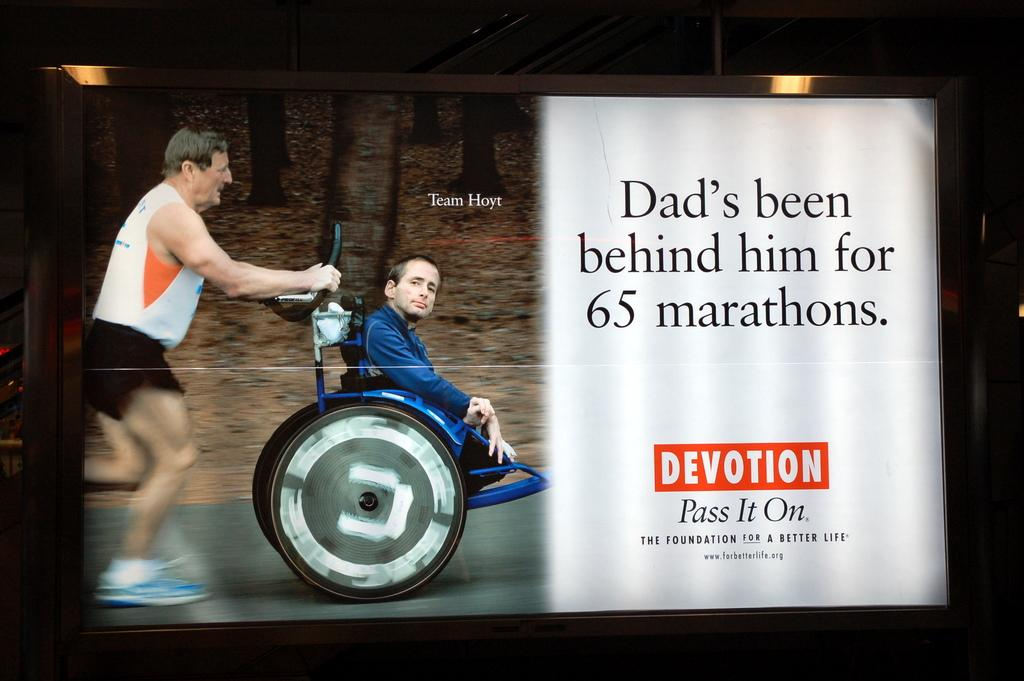What is the main subject of the image? The main subject of the image is a screen. What can be seen on the screen? Two people, a wheelchair, trees, and some text are visible on the screen. Can you describe the people on the screen? Unfortunately, the image does not provide enough detail to describe the people on the screen. What is the color of the background in the image? The background of the image is dark. How many ladybugs are crawling on the gold cannon in the image? There are no ladybugs or gold cannons present in the image. 